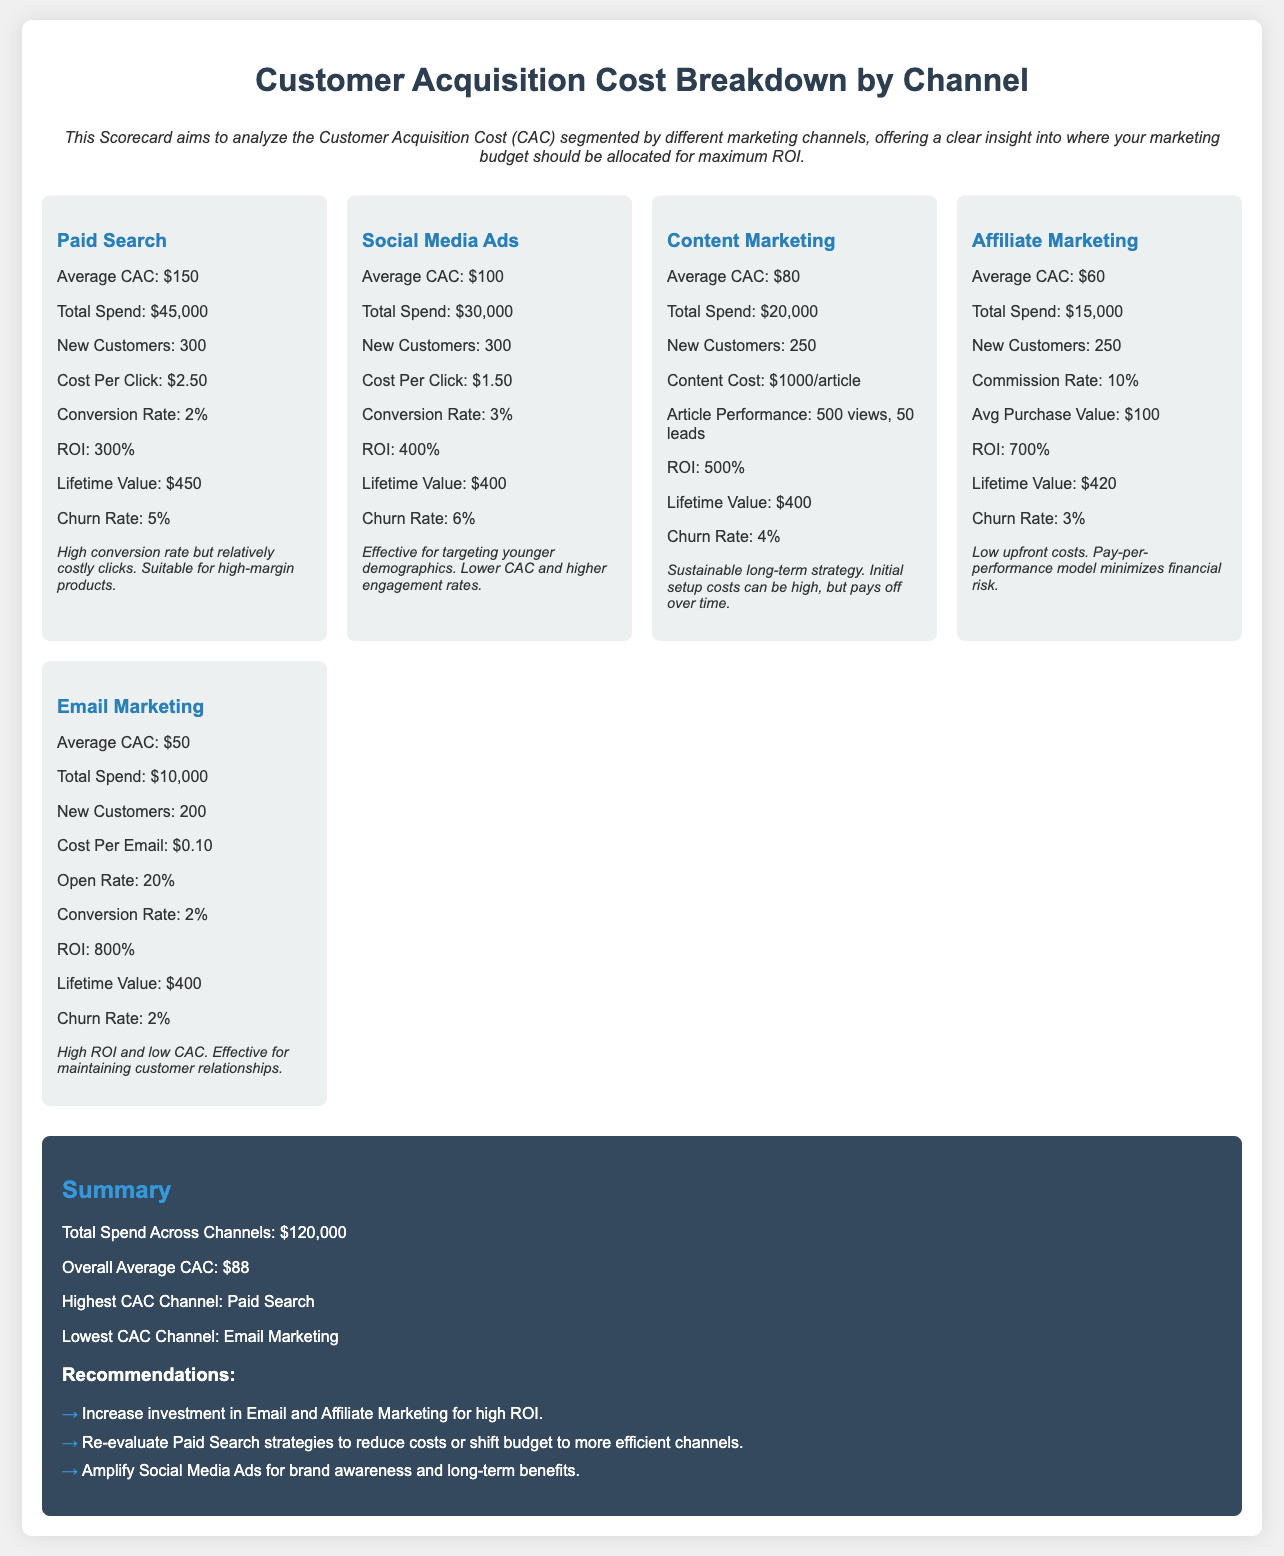What is the average Customer Acquisition Cost for Paid Search? The average Customer Acquisition Cost for Paid Search is explicitly stated in the document.
Answer: $150 What is the total spend for Social Media Ads? The document lists the total spend for Social Media Ads, providing clear financial information.
Answer: $30,000 How many new customers were acquired through Email Marketing? The document indicates the number of new customers acquired through Email Marketing.
Answer: 200 Which channel has the highest ROI? The document outlines key metrics, including ROI for each channel, allowing for straightforward comparison.
Answer: Affiliate Marketing What is the average Customer Acquisition Cost across all channels? The summary section provides the overall average CAC calculated from all channels.
Answer: $88 Which marketing channel has the lowest churn rate? The churn rate is provided for each channel, allowing for comparison to identify the lowest rate.
Answer: Email Marketing What is the cost per click for Social Media Ads? The cost per click for Social Media Ads is specifically mentioned in the channel's cost breakdown.
Answer: $1.50 What is the average lifetime value for customers from Content Marketing? The document lists the average lifetime value for customers specifically linked to Content Marketing.
Answer: $400 What recommendation is given for Paid Search strategies? The recommendation section provides insights on how to adjust strategies for more efficiency.
Answer: Re-evaluate Paid Search strategies to reduce costs or shift budget to more efficient channels 